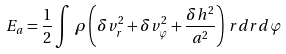<formula> <loc_0><loc_0><loc_500><loc_500>E _ { a } = \frac { 1 } { 2 } \int \, \rho \left ( \delta v _ { r } ^ { 2 } + \delta v _ { \varphi } ^ { 2 } + \frac { \delta h ^ { 2 } } { a ^ { 2 } } \right ) \, r d r d \varphi</formula> 